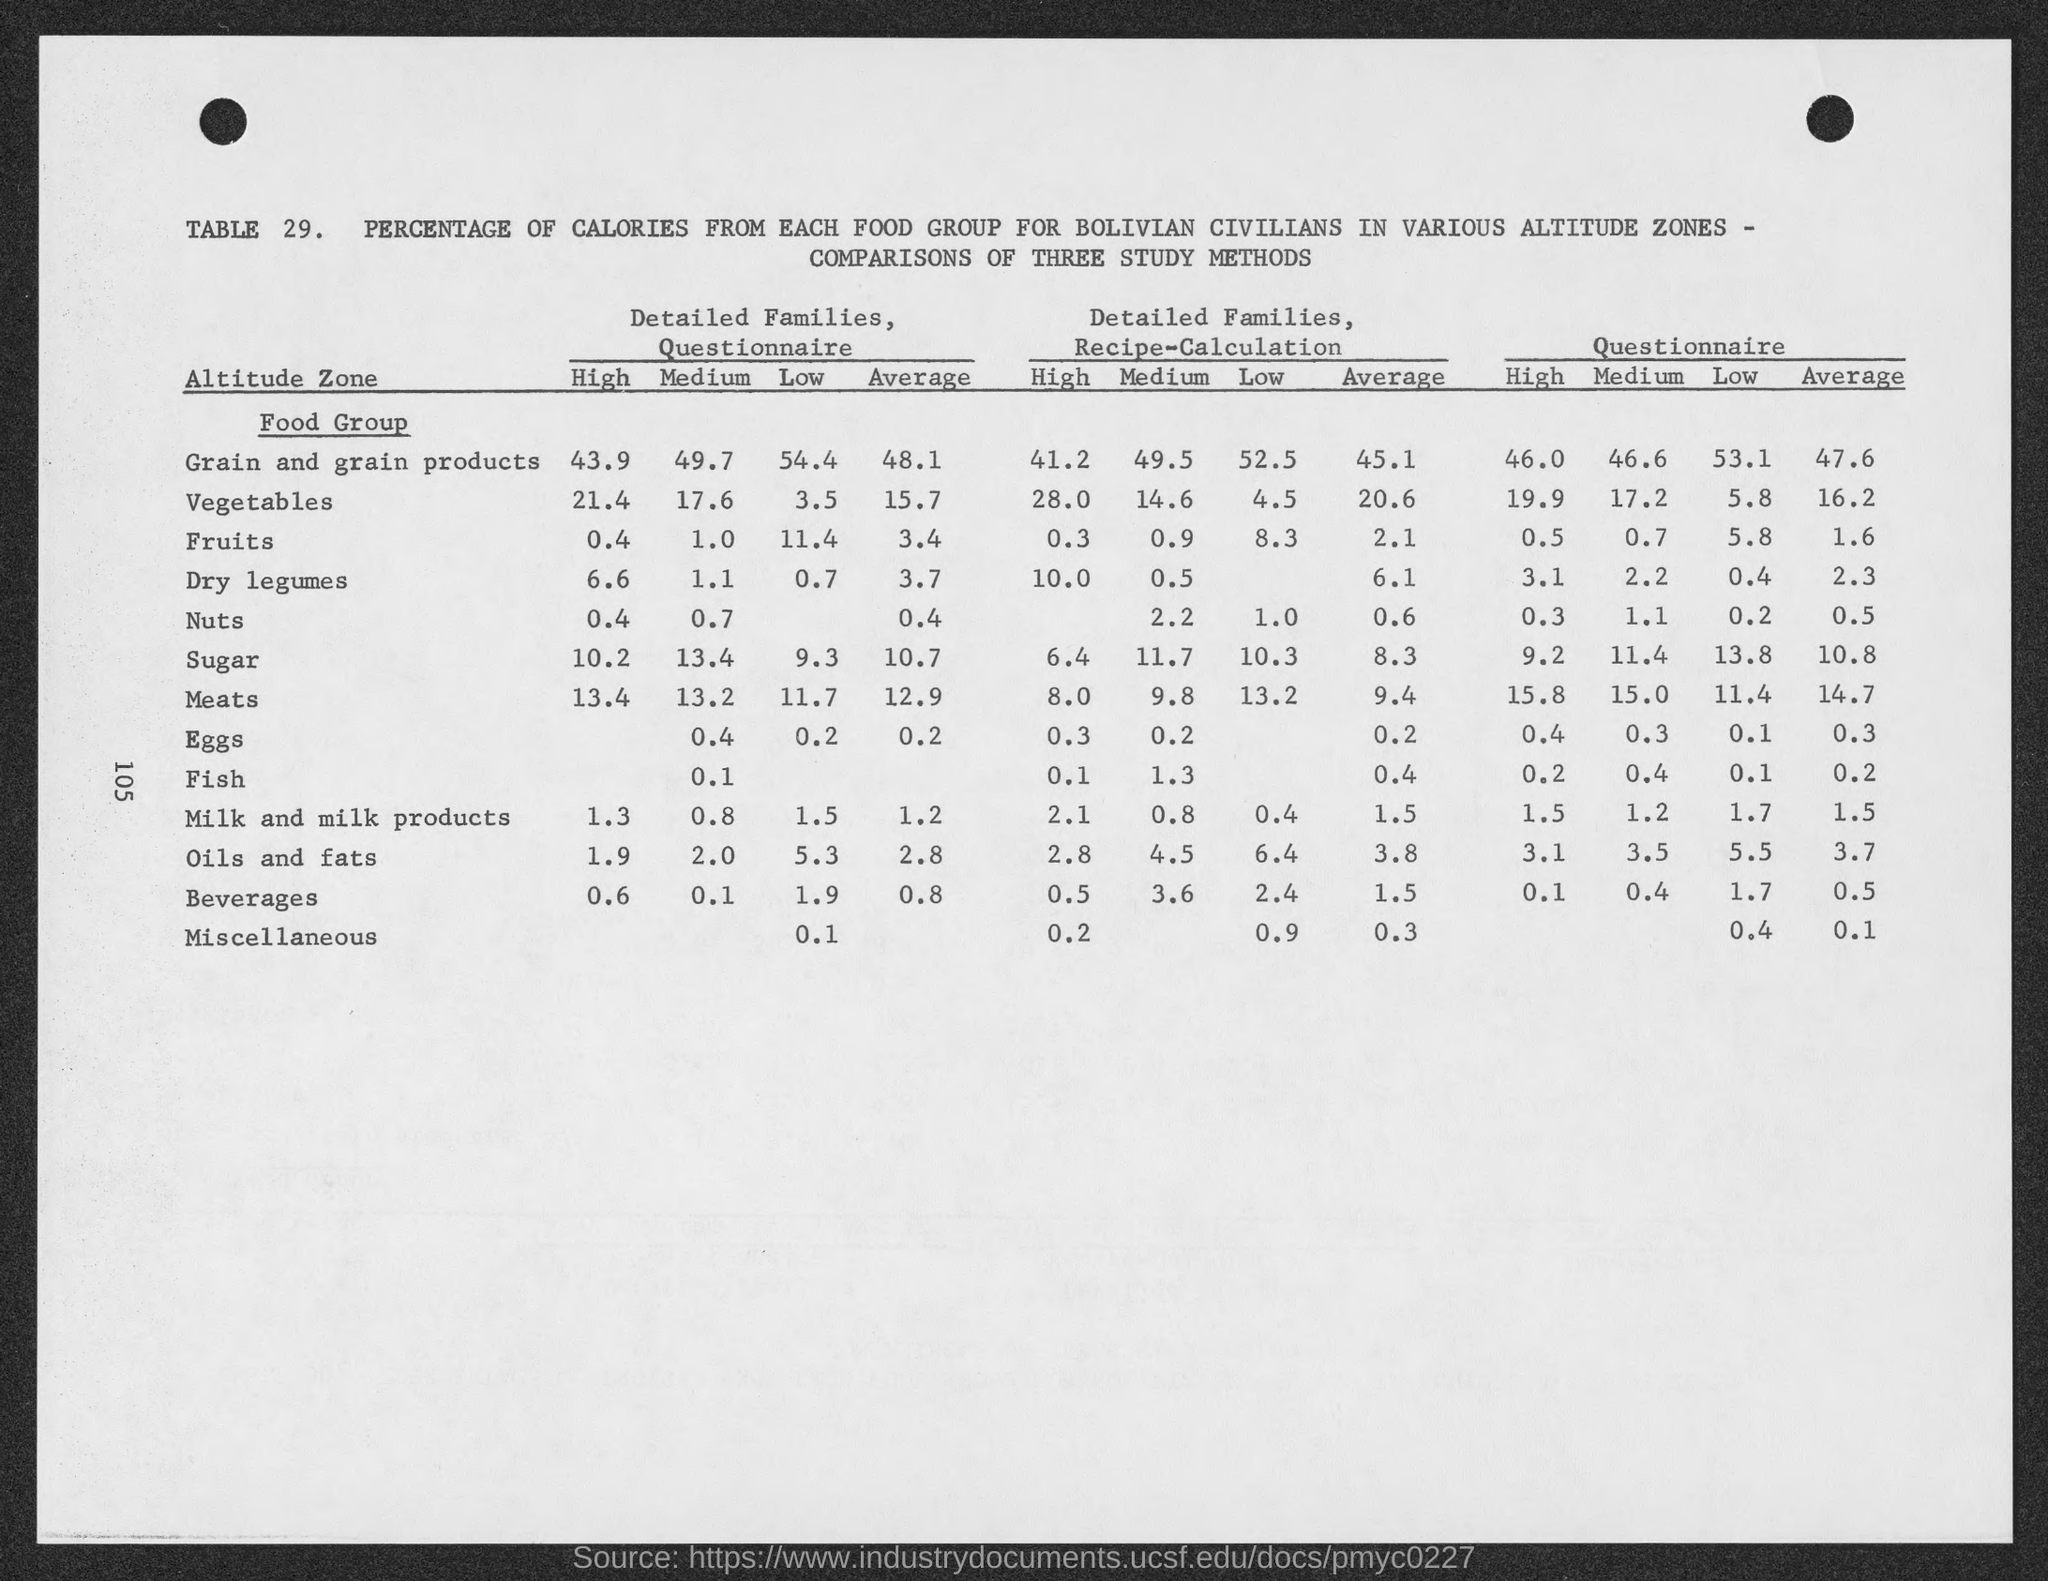What is the "High" for Detailed Families, Questionnaire for Grain and and Grain products?
Keep it short and to the point. 43.9. What is the "Medium" for Detailed Families, Questionnaire for Grain and and Grain products?
Provide a succinct answer. 49.7. What is the "Low" for Detailed Families, Questionnaire for Grain and and Grain products?
Offer a very short reply. 54.4. What is the "Average" for Detailed Families, Questionnaire for Grain and and Grain products?
Make the answer very short. 48.1. What is the "High" for Detailed Families, Questionnaire for Vegetables?
Keep it short and to the point. 21.4. What is the "High" for Detailed Families, Questionnaire for Fruits?
Offer a very short reply. 0.4. What is the "High" for Detailed Families, Questionnaire for Dry Legumes?
Your answer should be compact. 6.6. What is the "High" for Detailed Families, Questionnaire for Nuts?
Offer a terse response. 0.4. What is the "High" for Detailed Families, Questionnaire for sugar?
Your response must be concise. 10.2. What is the "High" for Detailed Families, Questionnaire for Meat?
Make the answer very short. 13.4. 